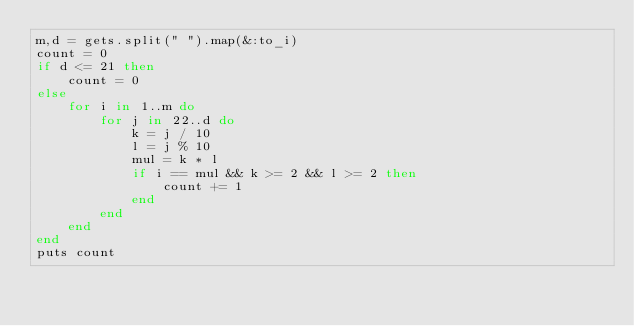Convert code to text. <code><loc_0><loc_0><loc_500><loc_500><_Ruby_>m,d = gets.split(" ").map(&:to_i)
count = 0
if d <= 21 then
    count = 0
else
    for i in 1..m do
        for j in 22..d do
            k = j / 10 
            l = j % 10
            mul = k * l
            if i == mul && k >= 2 && l >= 2 then
                count += 1
            end
        end
    end
end
puts count</code> 